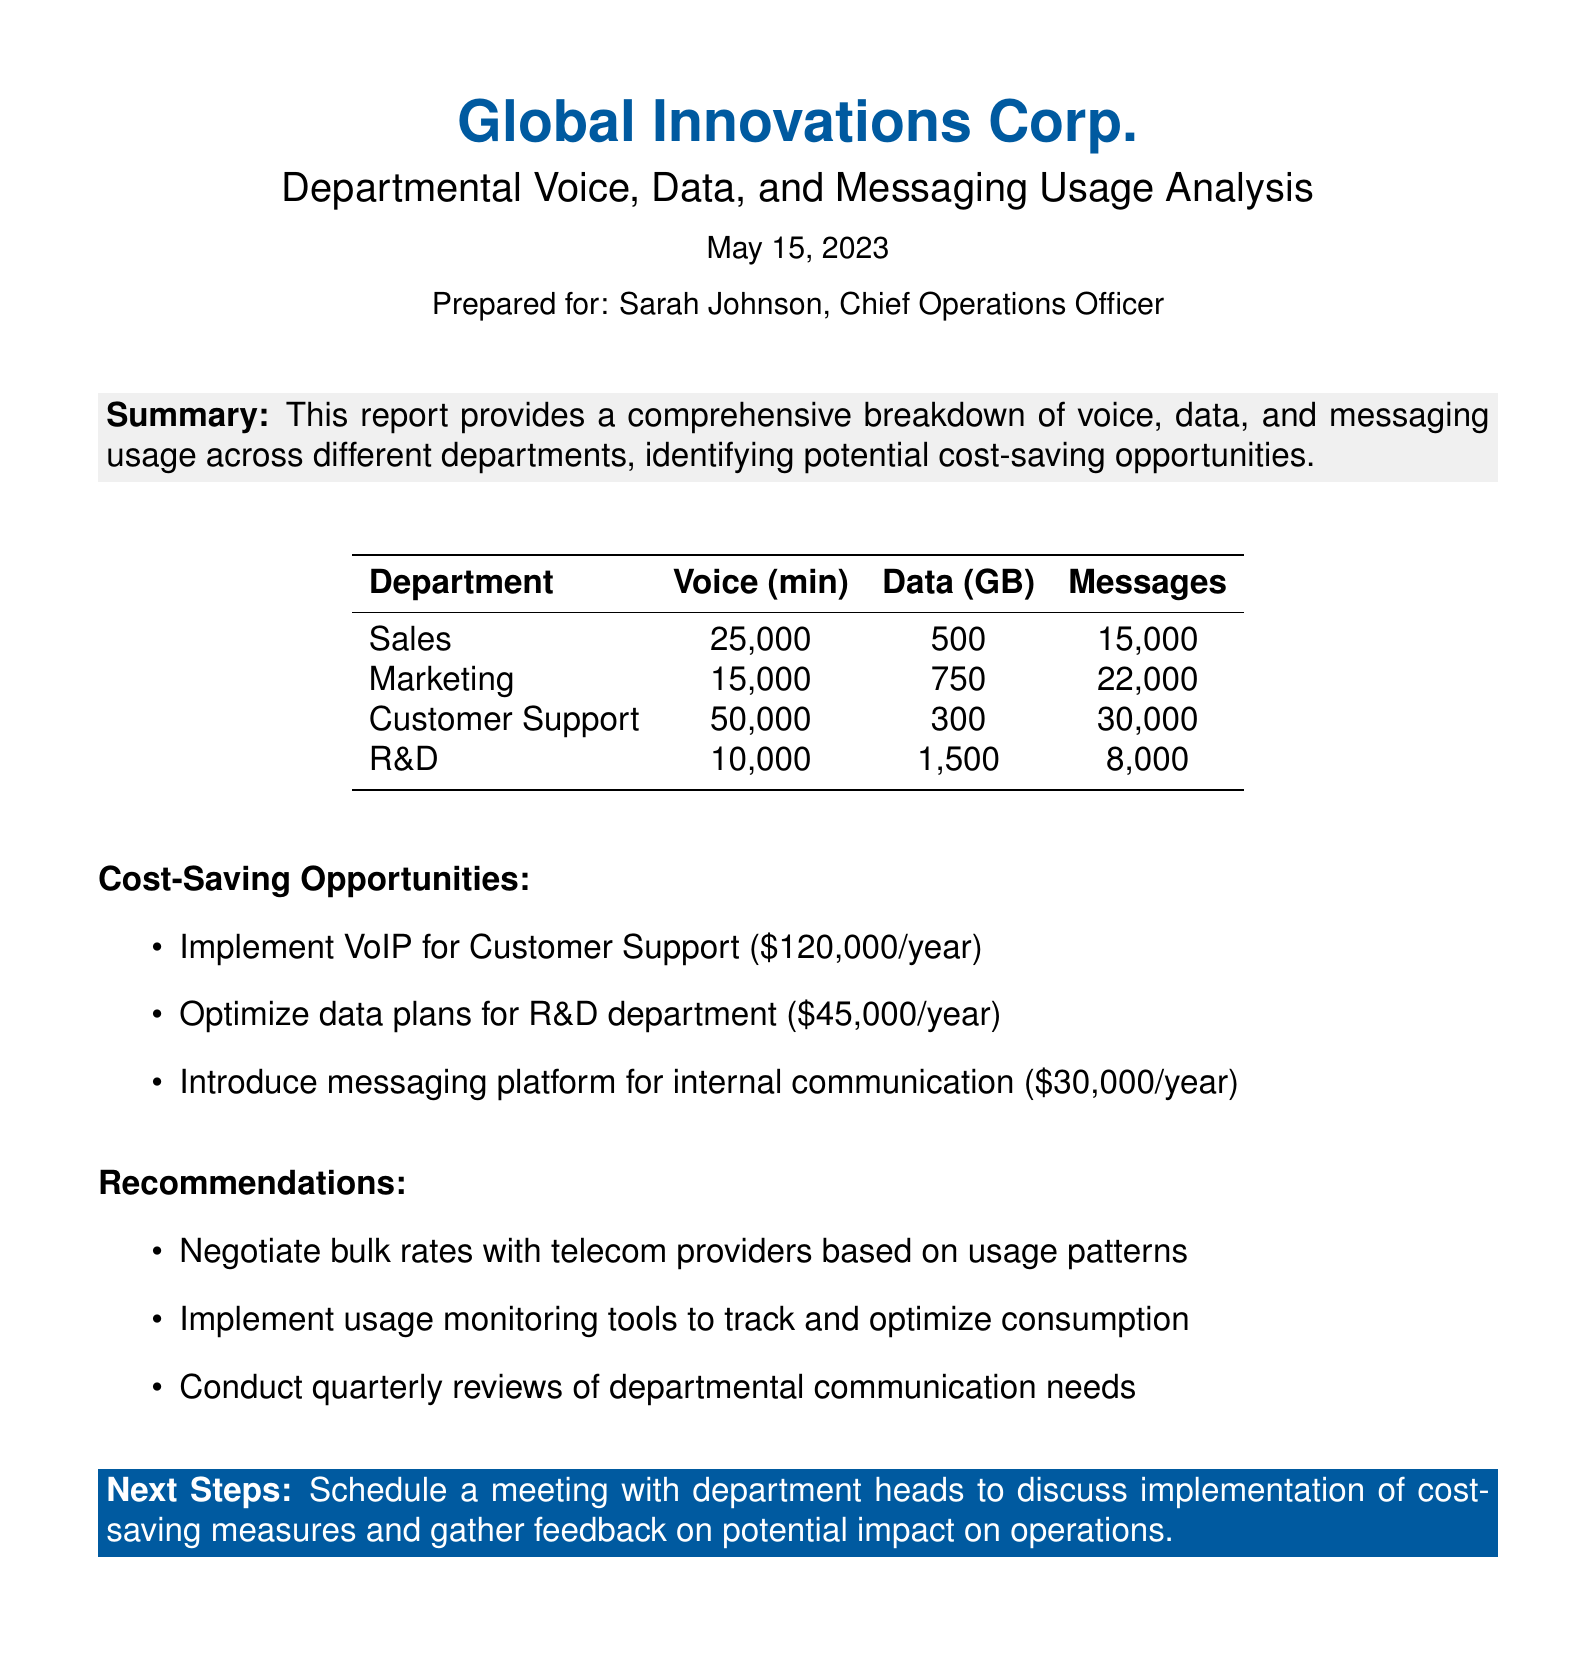What is the total voice usage in the Sales department? The voice usage in the Sales department is noted as 25,000 minutes in the table.
Answer: 25,000 minutes How much data is used by the R&D department? The data usage for the R&D department is listed as 1,500 GB in the report.
Answer: 1,500 GB How many messages were sent from the Customer Support department? The number of messages sent from the Customer Support department is provided as 30,000 in the table.
Answer: 30,000 What is the suggested cost-saving from implementing VoIP for Customer Support? The document states that implementing VoIP for Customer Support could save $120,000 per year.
Answer: $120,000/year Which department has the highest messaging usage? The department with the highest messaging usage is Marketing, as indicated by 22,000 messages.
Answer: Marketing What is the total potential cost savings identified in the report? The total potential cost savings from all identified opportunities is $195,000 based on the individual savings listed.
Answer: $195,000 What is one recommendation made in the report? One recommendation in the report is to negotiate bulk rates with telecom providers based on usage patterns.
Answer: Negotiate bulk rates What date was this report prepared? The report is prepared on May 15, 2023, as mentioned in the header.
Answer: May 15, 2023 Which department has the lowest voice usage? The department with the lowest voice usage is R&D, with 10,000 minutes as per the details in the table.
Answer: R&D 